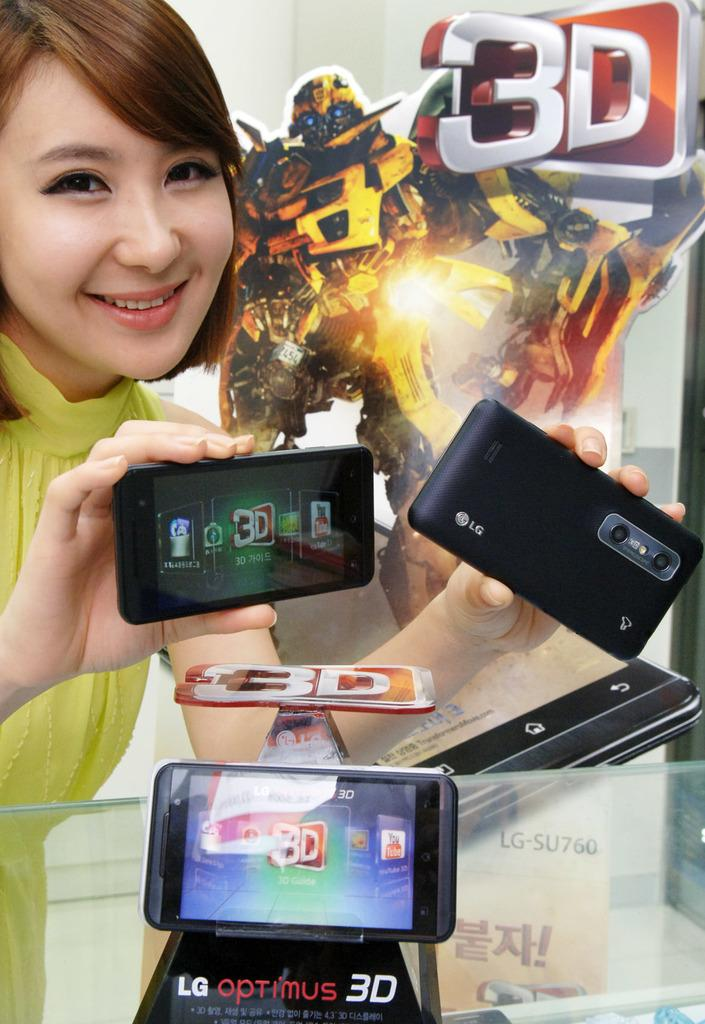<image>
Render a clear and concise summary of the photo. An LG Optimus 3D display with a woman holding two of those phones. 